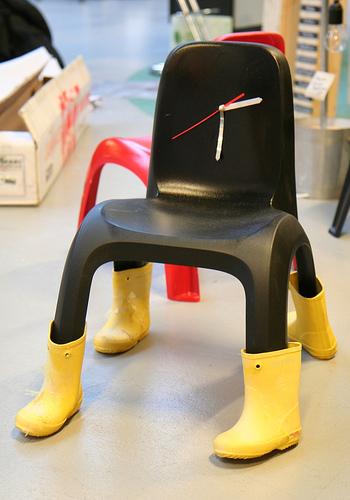Who made this chair for children?
Concise answer only. Don't know. What are the legs on the chair made of?
Be succinct. Plastic. What are on the legs of the chair?
Concise answer only. Boots. 